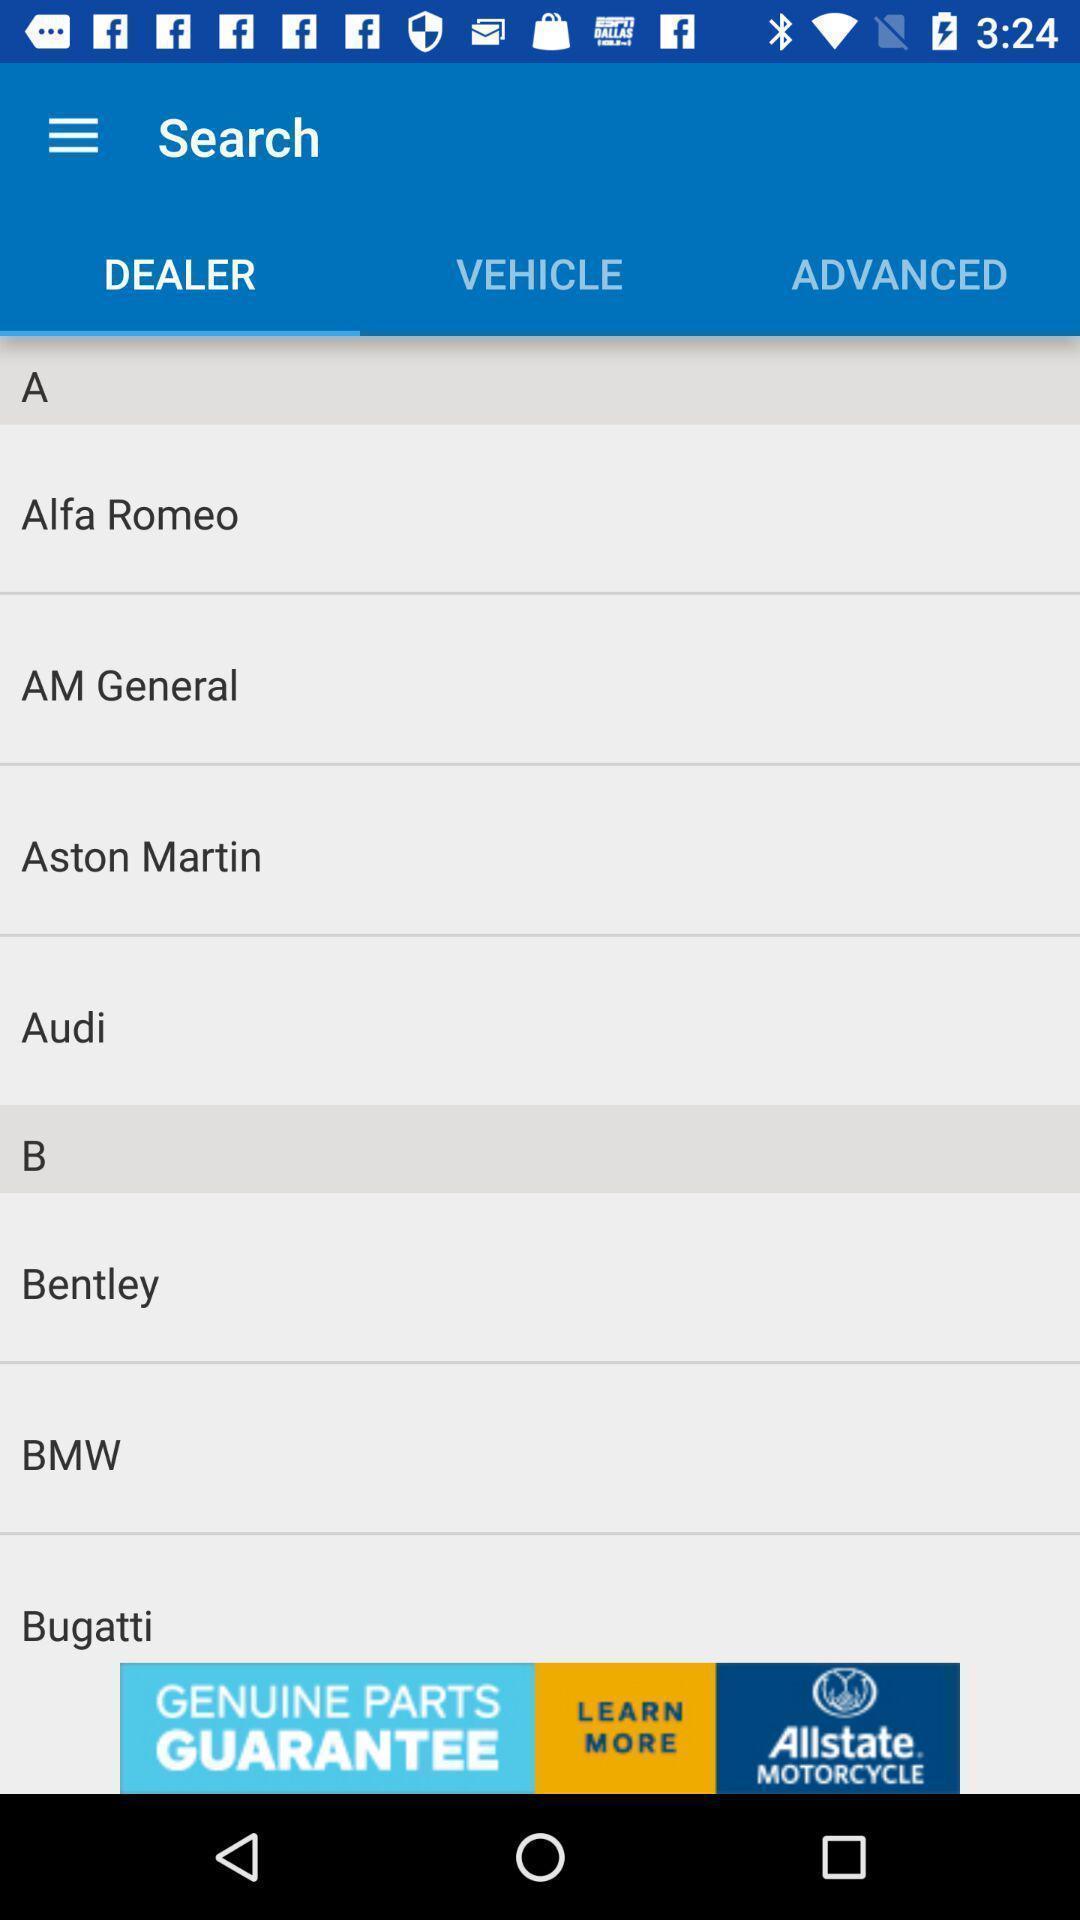Tell me what you see in this picture. Screen page displaying various automobile companies. 